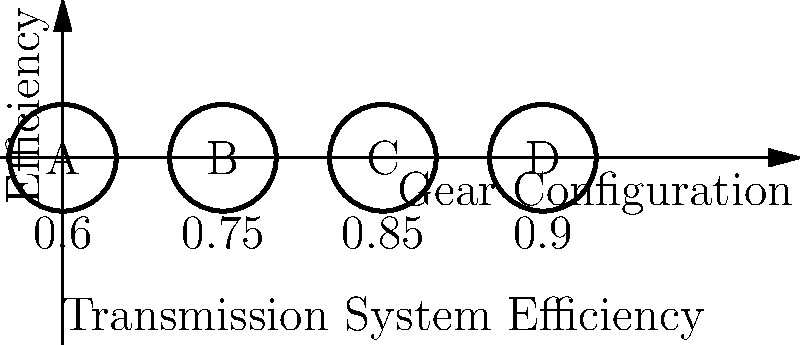In a competitive analysis of a startup's new transmission system, you've obtained efficiency data for four different gear configurations (A, B, C, and D) as shown in the diagram. If the startup claims their system can achieve an overall efficiency of 85% when combining three of these gears in series, what is the maximum number of possible gear combinations that could meet or exceed this claim? Let's approach this step-by-step:

1) We need to consider all possible combinations of three gears and calculate their combined efficiency.

2) The combined efficiency of gears in series is the product of their individual efficiencies.

3) We have 4 gears to choose from, and we need to select 3. This gives us $\binom{4}{3} = 4$ possible combinations.

4) Let's calculate the efficiency for each combination:

   a) A, B, C: $0.6 \times 0.75 \times 0.85 = 0.3825$ or 38.25%
   b) A, B, D: $0.6 \times 0.75 \times 0.9 = 0.405$ or 40.5%
   c) A, C, D: $0.6 \times 0.85 \times 0.9 = 0.459$ or 45.9%
   d) B, C, D: $0.75 \times 0.85 \times 0.9 = 0.57375$ or 57.375%

5) The startup claims 85% efficiency, which is 0.85 in decimal form.

6) Comparing our calculated efficiencies to 0.85, we can see that none of the combinations meet or exceed this claim.

Therefore, the maximum number of possible gear combinations that could meet or exceed the startup's claim is 0.
Answer: 0 